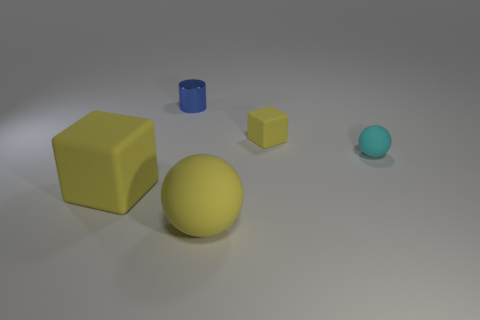What can you infer about the lighting in this scene based on the shadows? The lighting in the scene appears to be coming from the upper left side, as indicated by the shadows that each object casts towards the bottom right. This suggests a single light source, likely positioned at an angle, illuminating the scene asymmetrically. 